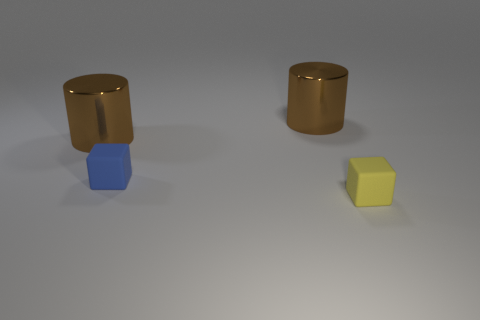Add 3 yellow matte blocks. How many objects exist? 7 Subtract 0 red balls. How many objects are left? 4 Subtract all large cyan objects. Subtract all large brown metal cylinders. How many objects are left? 2 Add 4 brown metal cylinders. How many brown metal cylinders are left? 6 Add 1 yellow cubes. How many yellow cubes exist? 2 